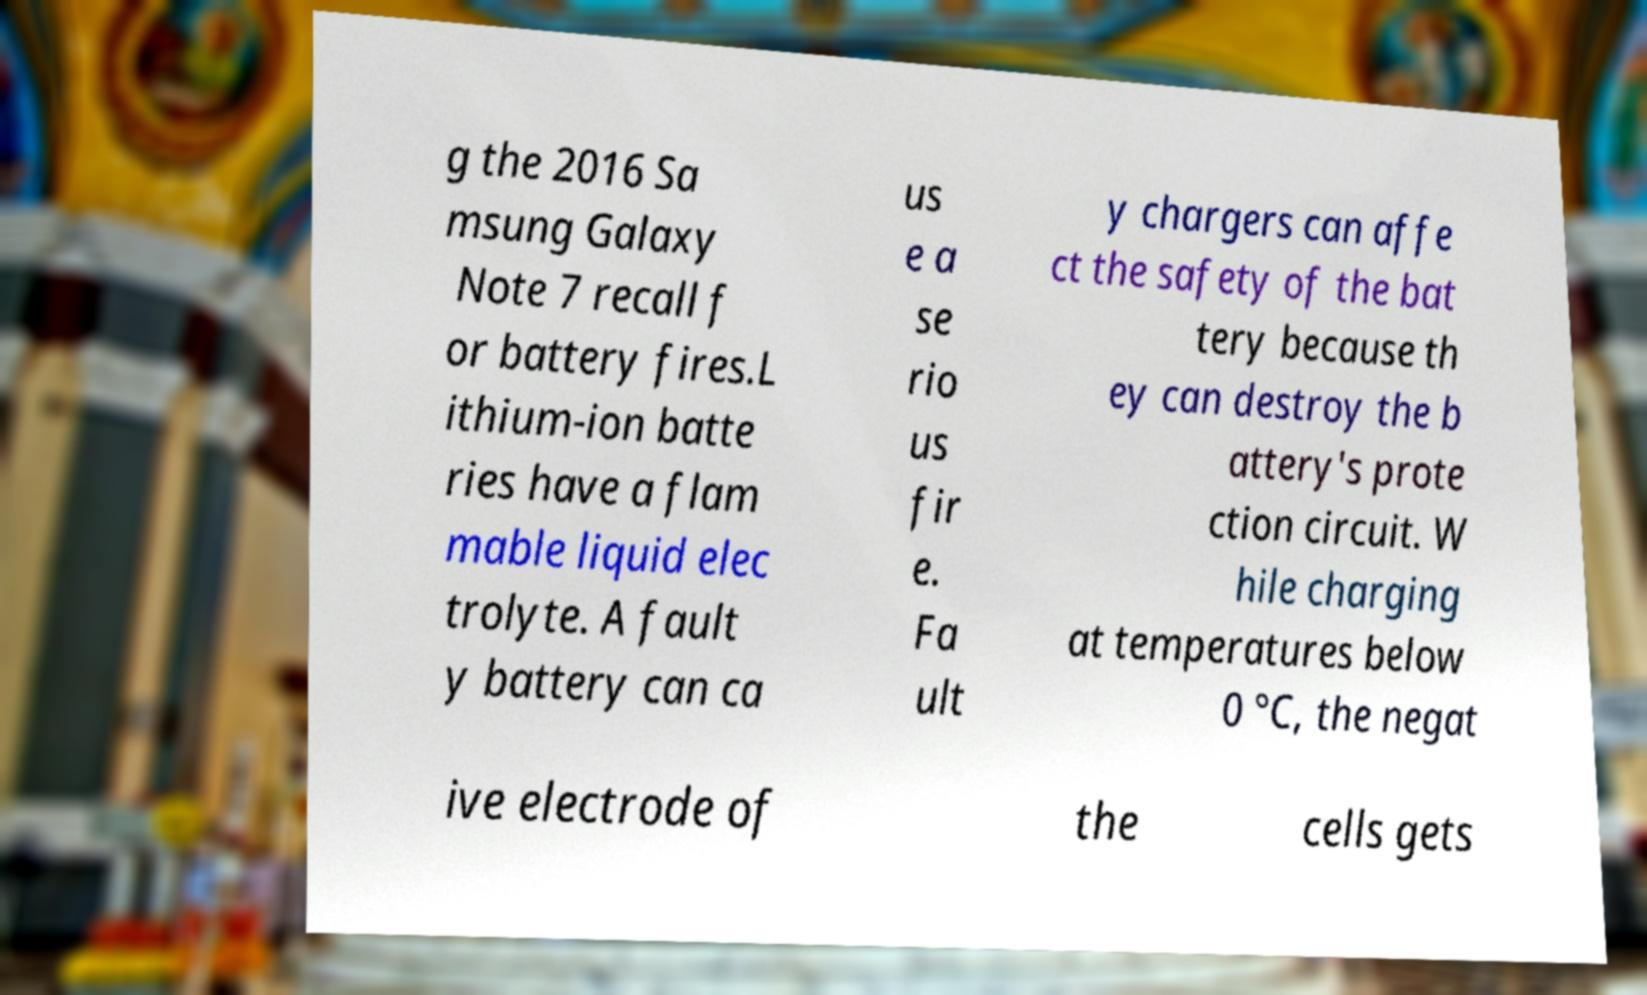For documentation purposes, I need the text within this image transcribed. Could you provide that? g the 2016 Sa msung Galaxy Note 7 recall f or battery fires.L ithium-ion batte ries have a flam mable liquid elec trolyte. A fault y battery can ca us e a se rio us fir e. Fa ult y chargers can affe ct the safety of the bat tery because th ey can destroy the b attery's prote ction circuit. W hile charging at temperatures below 0 °C, the negat ive electrode of the cells gets 